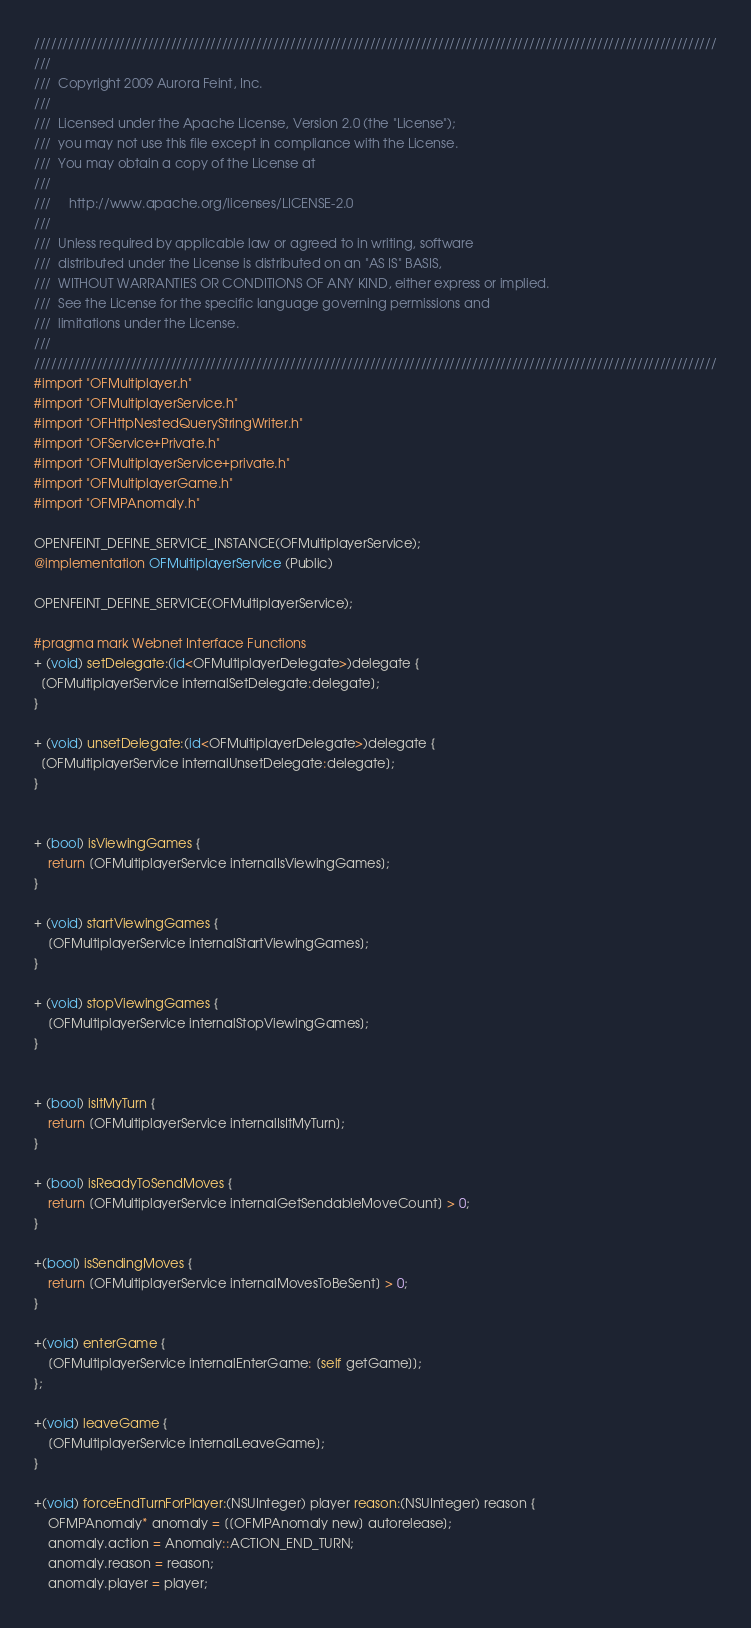Convert code to text. <code><loc_0><loc_0><loc_500><loc_500><_ObjectiveC_>////////////////////////////////////////////////////////////////////////////////////////////////////////////////////////
/// 
///  Copyright 2009 Aurora Feint, Inc.
/// 
///  Licensed under the Apache License, Version 2.0 (the "License");
///  you may not use this file except in compliance with the License.
///  You may obtain a copy of the License at
///  
///  	http://www.apache.org/licenses/LICENSE-2.0
///  	
///  Unless required by applicable law or agreed to in writing, software
///  distributed under the License is distributed on an "AS IS" BASIS,
///  WITHOUT WARRANTIES OR CONDITIONS OF ANY KIND, either express or implied.
///  See the License for the specific language governing permissions and
///  limitations under the License.
/// 
////////////////////////////////////////////////////////////////////////////////////////////////////////////////////////
#import "OFMultiplayer.h"
#import "OFMultiplayerService.h"
#import "OFHttpNestedQueryStringWriter.h"
#import "OFService+Private.h"
#import "OFMultiplayerService+private.h"
#import "OFMultiplayerGame.h"
#import "OFMPAnomaly.h"

OPENFEINT_DEFINE_SERVICE_INSTANCE(OFMultiplayerService);
@implementation OFMultiplayerService (Public)

OPENFEINT_DEFINE_SERVICE(OFMultiplayerService);

#pragma mark Webnet Interface Functions
+ (void) setDelegate:(id<OFMultiplayerDelegate>)delegate {
  [OFMultiplayerService internalSetDelegate:delegate];
}

+ (void) unsetDelegate:(id<OFMultiplayerDelegate>)delegate {
  [OFMultiplayerService internalUnsetDelegate:delegate];
}


+ (bool) isViewingGames {
	return [OFMultiplayerService internalIsViewingGames];
}

+ (void) startViewingGames {
	[OFMultiplayerService internalStartViewingGames];
}

+ (void) stopViewingGames {
	[OFMultiplayerService internalStopViewingGames];
}


+ (bool) isItMyTurn {
    return [OFMultiplayerService internalIsItMyTurn];
}

+ (bool) isReadyToSendMoves {
    return [OFMultiplayerService internalGetSendableMoveCount] > 0;
}

+(bool) isSendingMoves {
    return [OFMultiplayerService internalMovesToBeSent] > 0;
}

+(void) enterGame {
	[OFMultiplayerService internalEnterGame: [self getGame]];
};

+(void) leaveGame {
	[OFMultiplayerService internalLeaveGame];
}

+(void) forceEndTurnForPlayer:(NSUInteger) player reason:(NSUInteger) reason {
    OFMPAnomaly* anomaly = [[OFMPAnomaly new] autorelease];
    anomaly.action = Anomaly::ACTION_END_TURN;
    anomaly.reason = reason;
    anomaly.player = player;</code> 